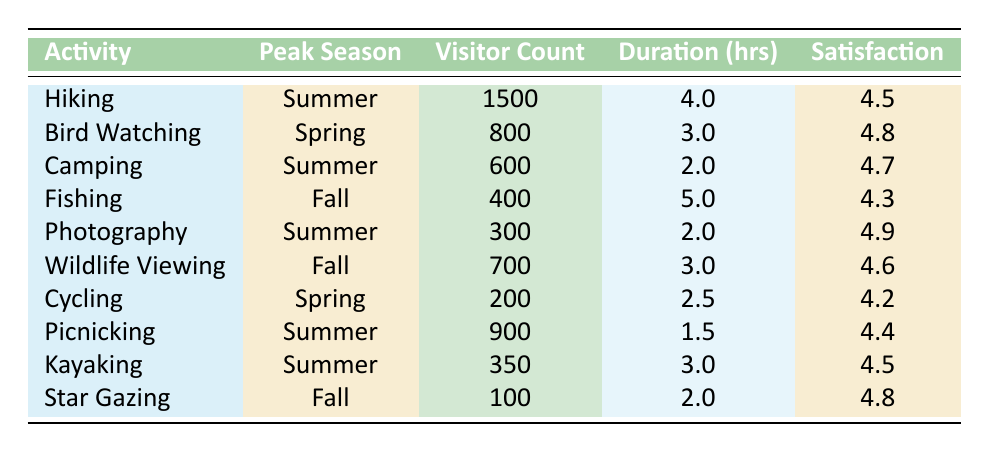What is the total visitor count for the Summer activities? From the table, the activities in Summer are Hiking (1500), Camping (600), Photography (300), Picnicking (900), and Kayaking (350). Adding these numbers together gives us 1500 + 600 + 300 + 900 + 350 = 3850.
Answer: 3850 Which activity has the highest satisfaction rating? The satisfaction ratings from the table are: Hiking (4.5), Bird Watching (4.8), Camping (4.7), Fishing (4.3), Photography (4.9), Wildlife Viewing (4.6), Cycling (4.2), Picnicking (4.4), Kayaking (4.5), and Star Gazing (4.8). The highest rating is for Photography, which has a satisfaction rating of 4.9.
Answer: Photography (4.9) Is the visitor count for Fishing greater than the visitor count for Cycling? The visitor count for Fishing is 400, and the visitor count for Cycling is 200. Since 400 is greater than 200, the statement is true.
Answer: Yes What is the average duration of activities during the Fall season? The activities in Fall are Fishing (5 hours), Wildlife Viewing (3 hours), and Star Gazing (2 hours). To calculate the average, we first sum the durations: 5 + 3 + 2 = 10 hours. Then divide by the number of activities, which is 3: 10 / 3 = approximately 3.33 hours.
Answer: Approximately 3.33 hours How many activities have a satisfaction rating of 4.5 or higher? By reviewing the satisfaction ratings, we find the following activities meet that criteria: Hiking (4.5), Bird Watching (4.8), Camping (4.7), Photography (4.9), Wildlife Viewing (4.6), Picnicking (4.4), Kayaking (4.5), and Star Gazing (4.8). Counting these activities gives us 8 activities with ratings of 4.5 or higher.
Answer: 8 activities Which peak season had the least visitor count and what was that count? The visitor counts for each season are Summer (3850), Spring (1000), and Fall (1200). The smallest count is for Spring with 800 visitors.
Answer: Spring (800) What is the difference in visitor count between Hiking and Wildlife Viewing? The visitor count for Hiking is 1500, and for Wildlife Viewing, it is 700. The difference is 1500 - 700 = 800.
Answer: 800 Are there any activities in Spring that have a satisfaction rating lower than 4.5? In Spring, the activities are Bird Watching (4.8) and Cycling (4.2). Since Cycling has a rating of 4.2, which is lower than 4.5, the answer is yes.
Answer: Yes 